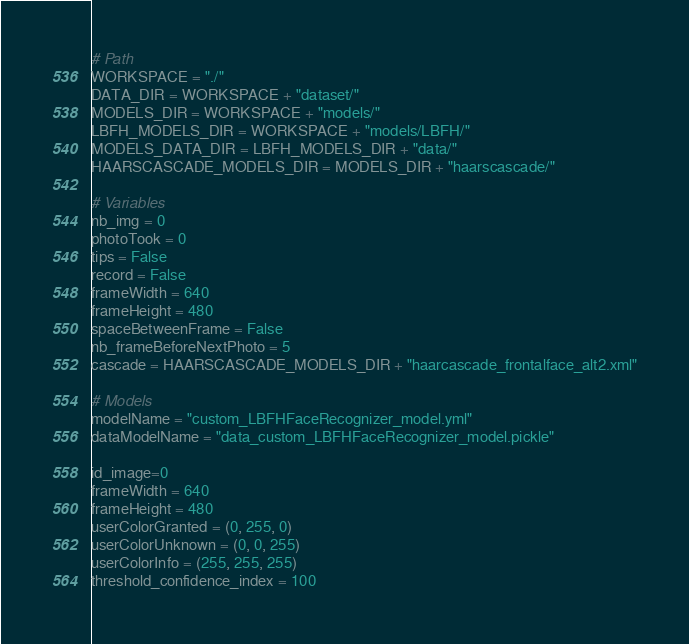Convert code to text. <code><loc_0><loc_0><loc_500><loc_500><_Python_># Path
WORKSPACE = "./"
DATA_DIR = WORKSPACE + "dataset/"
MODELS_DIR = WORKSPACE + "models/"
LBFH_MODELS_DIR = WORKSPACE + "models/LBFH/"
MODELS_DATA_DIR = LBFH_MODELS_DIR + "data/"
HAARSCASCADE_MODELS_DIR = MODELS_DIR + "haarscascade/"

# Variables
nb_img = 0
photoTook = 0
tips = False
record = False
frameWidth = 640
frameHeight = 480
spaceBetweenFrame = False
nb_frameBeforeNextPhoto = 5
cascade = HAARSCASCADE_MODELS_DIR + "haarcascade_frontalface_alt2.xml"

# Models
modelName = "custom_LBFHFaceRecognizer_model.yml"
dataModelName = "data_custom_LBFHFaceRecognizer_model.pickle"

id_image=0
frameWidth = 640
frameHeight = 480
userColorGranted = (0, 255, 0)
userColorUnknown = (0, 0, 255)
userColorInfo = (255, 255, 255)
threshold_confidence_index = 100
</code> 